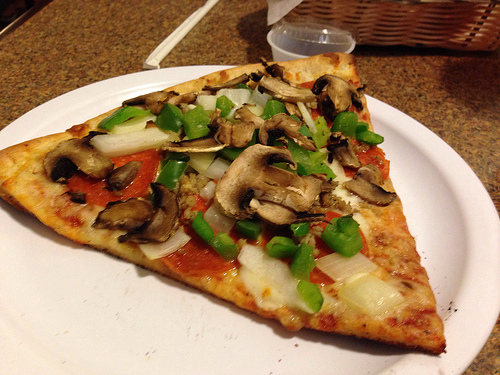Please provide a short description for this region: [0.41, 0.41, 0.62, 0.57]. This region of the image highlights a portion of a pizza topped with sautéed mushrooms. 